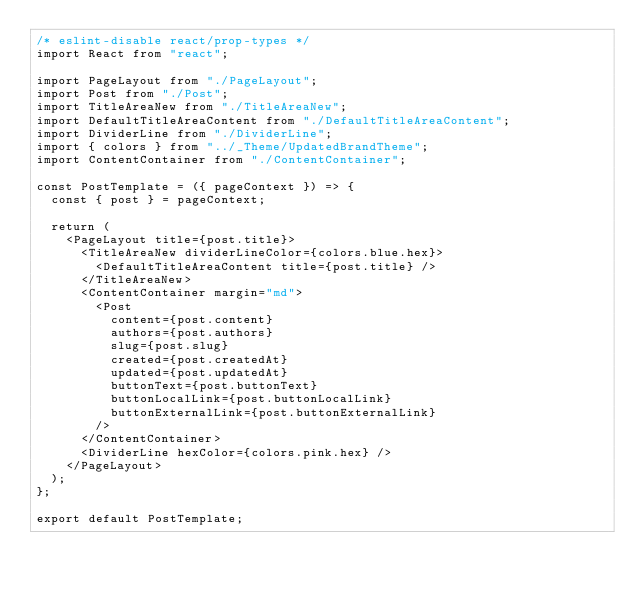<code> <loc_0><loc_0><loc_500><loc_500><_JavaScript_>/* eslint-disable react/prop-types */
import React from "react";

import PageLayout from "./PageLayout";
import Post from "./Post";
import TitleAreaNew from "./TitleAreaNew";
import DefaultTitleAreaContent from "./DefaultTitleAreaContent";
import DividerLine from "./DividerLine";
import { colors } from "../_Theme/UpdatedBrandTheme";
import ContentContainer from "./ContentContainer";

const PostTemplate = ({ pageContext }) => {
  const { post } = pageContext;

  return (
    <PageLayout title={post.title}>
      <TitleAreaNew dividerLineColor={colors.blue.hex}>
        <DefaultTitleAreaContent title={post.title} />
      </TitleAreaNew>
      <ContentContainer margin="md">
        <Post
          content={post.content}
          authors={post.authors}
          slug={post.slug}
          created={post.createdAt}
          updated={post.updatedAt}
          buttonText={post.buttonText}
          buttonLocalLink={post.buttonLocalLink}
          buttonExternalLink={post.buttonExternalLink}
        />
      </ContentContainer>
      <DividerLine hexColor={colors.pink.hex} />
    </PageLayout>
  );
};

export default PostTemplate;
</code> 